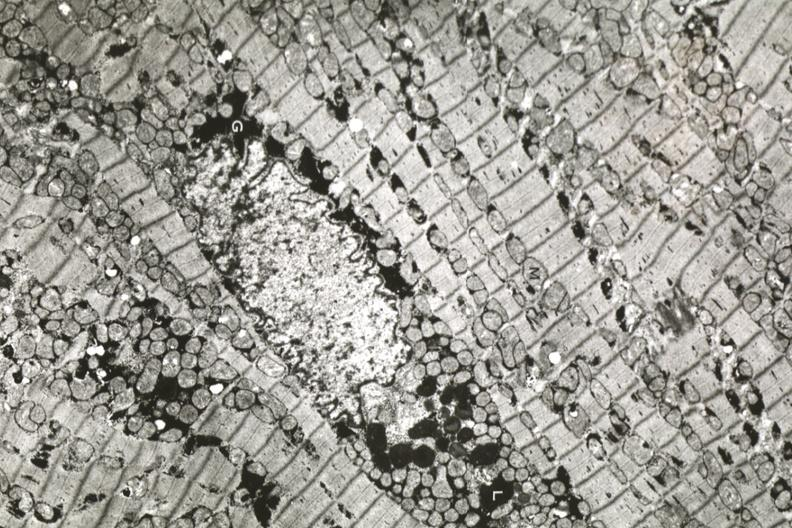what is present?
Answer the question using a single word or phrase. Atrophy 